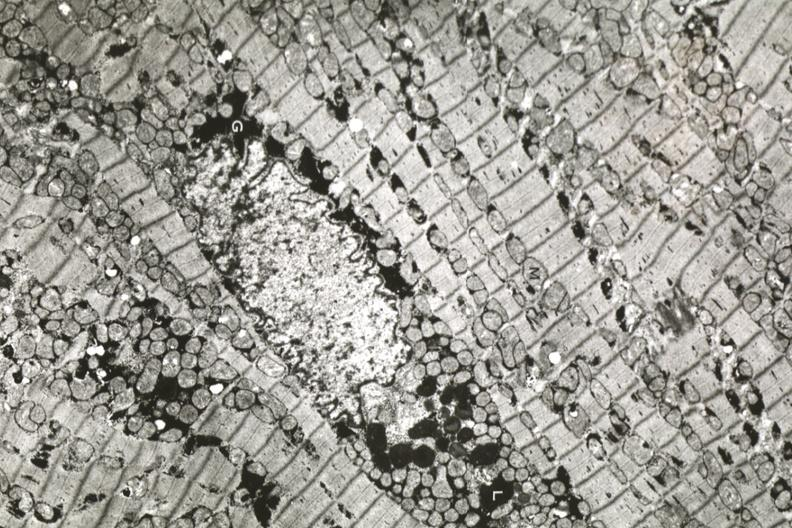what is present?
Answer the question using a single word or phrase. Atrophy 